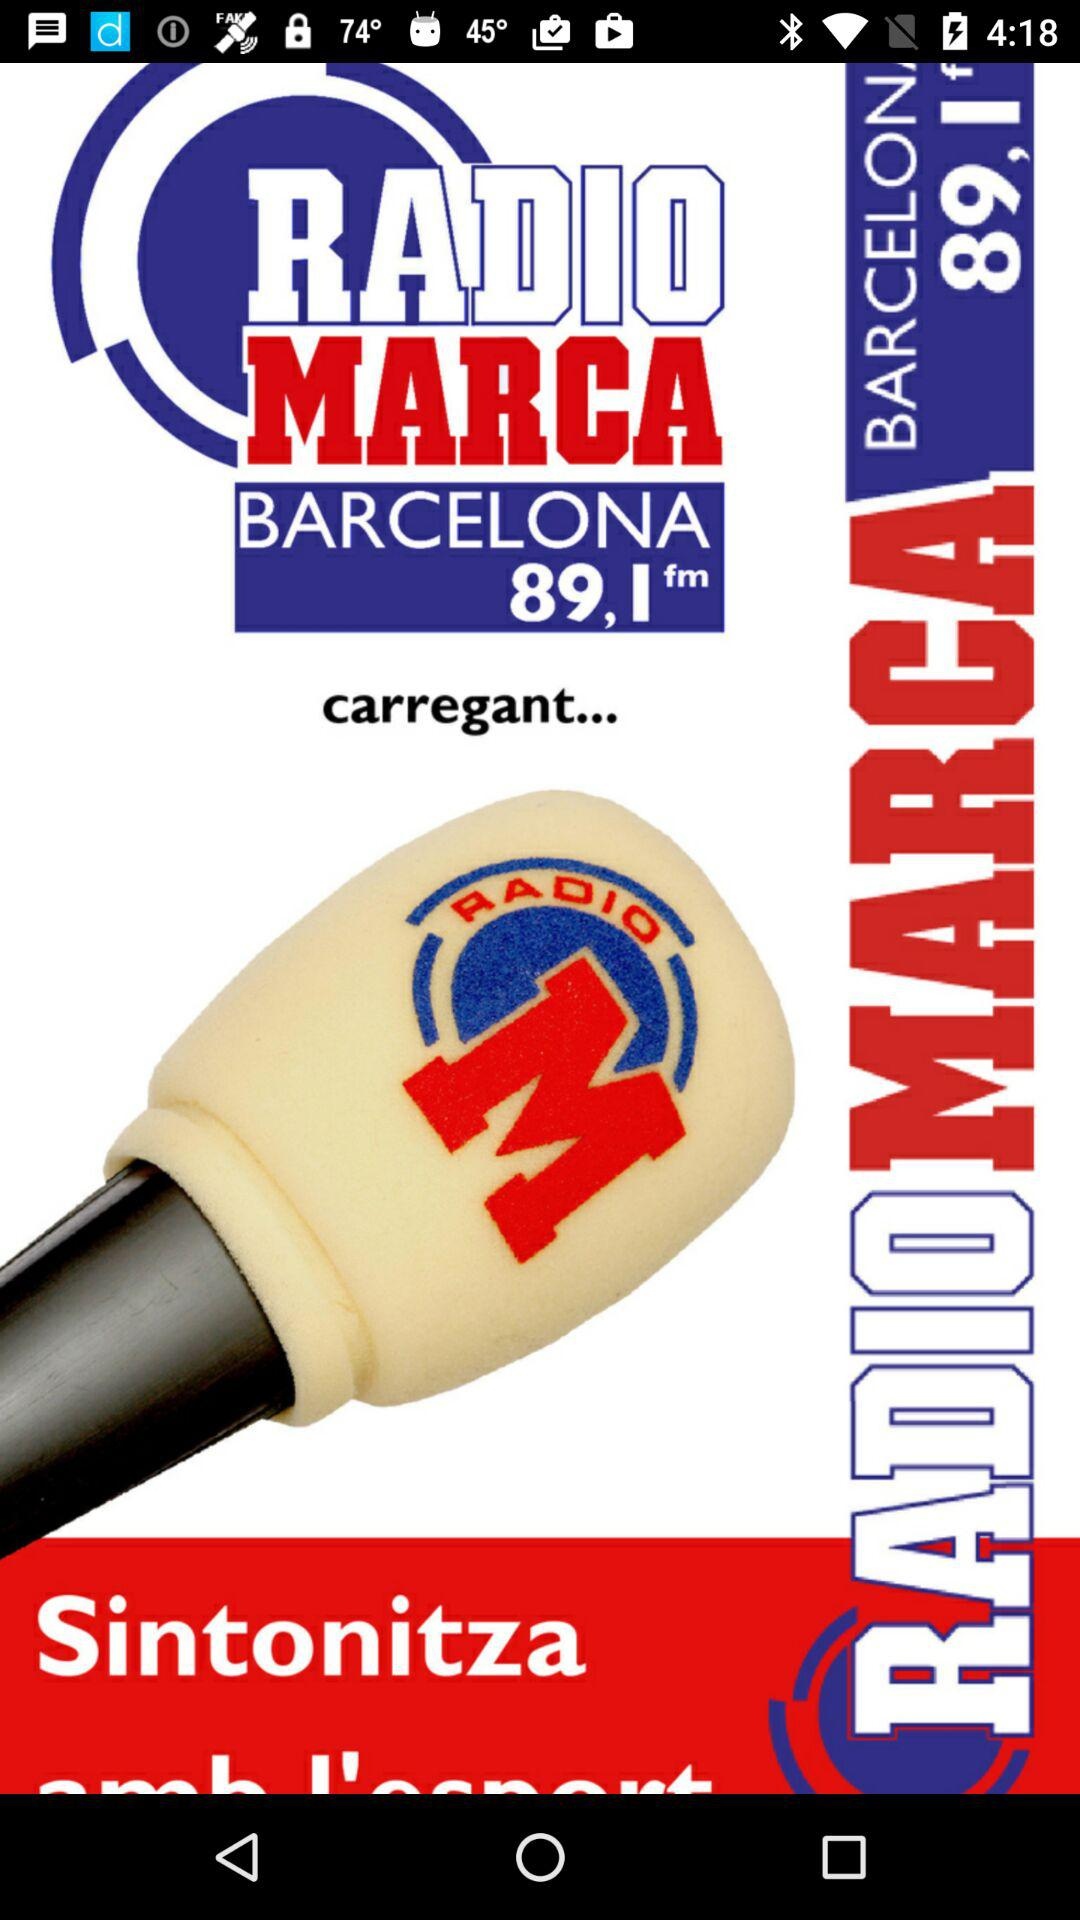What is the name of the application? The name of the application "RADIO MARCA BARCELONA 89,1fm". 